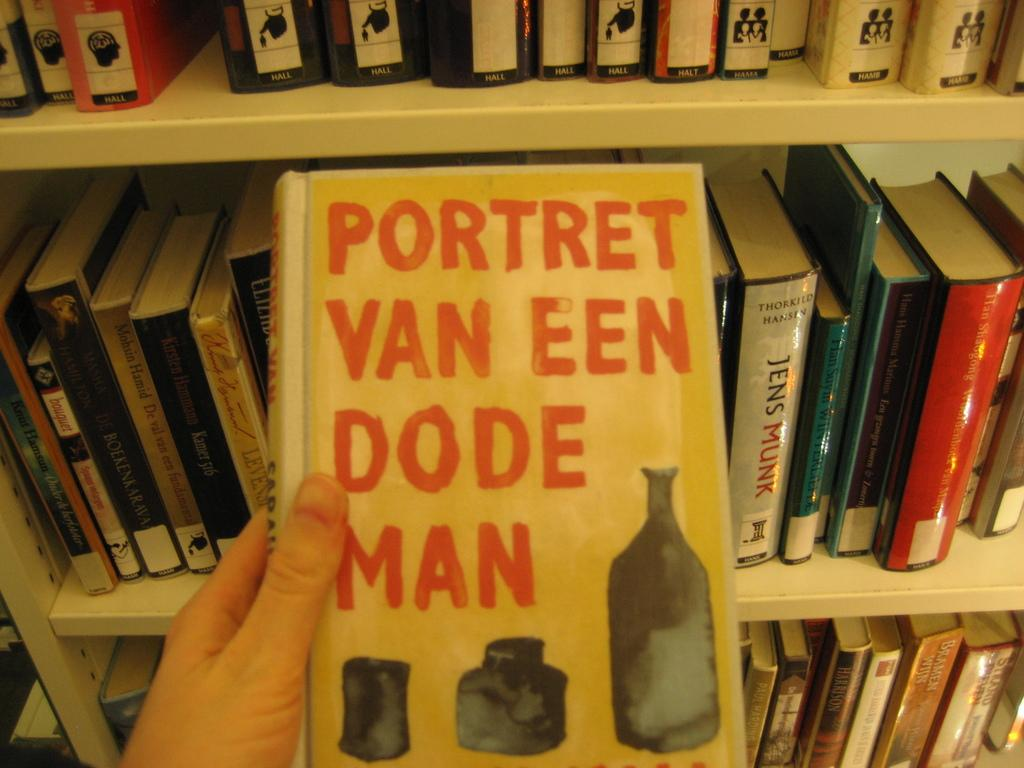<image>
Write a terse but informative summary of the picture. a person holds the book Portret Van Een Dode Man in front of a book case 